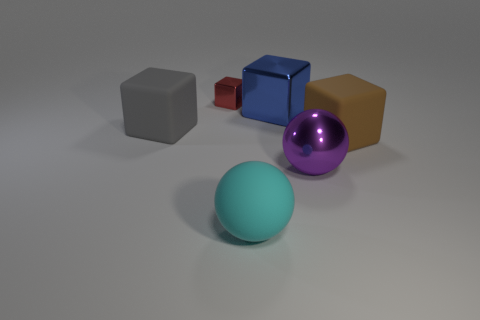Does the gray rubber object have the same shape as the shiny object that is left of the blue object?
Make the answer very short. Yes. The metal thing that is both behind the brown rubber object and in front of the red block is what color?
Ensure brevity in your answer.  Blue. The large ball in front of the large shiny sphere that is to the left of the cube in front of the big gray cube is made of what material?
Give a very brief answer. Rubber. What is the material of the big cyan ball?
Ensure brevity in your answer.  Rubber. There is a brown matte object that is the same shape as the large gray object; what is its size?
Your response must be concise. Large. Is the small object the same color as the rubber sphere?
Provide a short and direct response. No. What number of other things are there of the same material as the big brown cube
Provide a succinct answer. 2. Are there an equal number of big objects that are behind the big cyan matte thing and small gray matte balls?
Your answer should be compact. No. There is a matte cube that is in front of the gray object; does it have the same size as the small red shiny thing?
Give a very brief answer. No. There is a big cyan rubber object; what number of cubes are in front of it?
Offer a terse response. 0. 